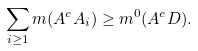Convert formula to latex. <formula><loc_0><loc_0><loc_500><loc_500>\sum _ { i \geq 1 } m ( A ^ { c } A _ { i } ) \geq m ^ { 0 } ( A ^ { c } D ) .</formula> 